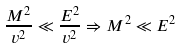Convert formula to latex. <formula><loc_0><loc_0><loc_500><loc_500>\frac { M ^ { 2 } } { v ^ { 2 } } \ll \frac { E ^ { 2 } } { v ^ { 2 } } \Rightarrow M ^ { 2 } \ll E ^ { 2 }</formula> 